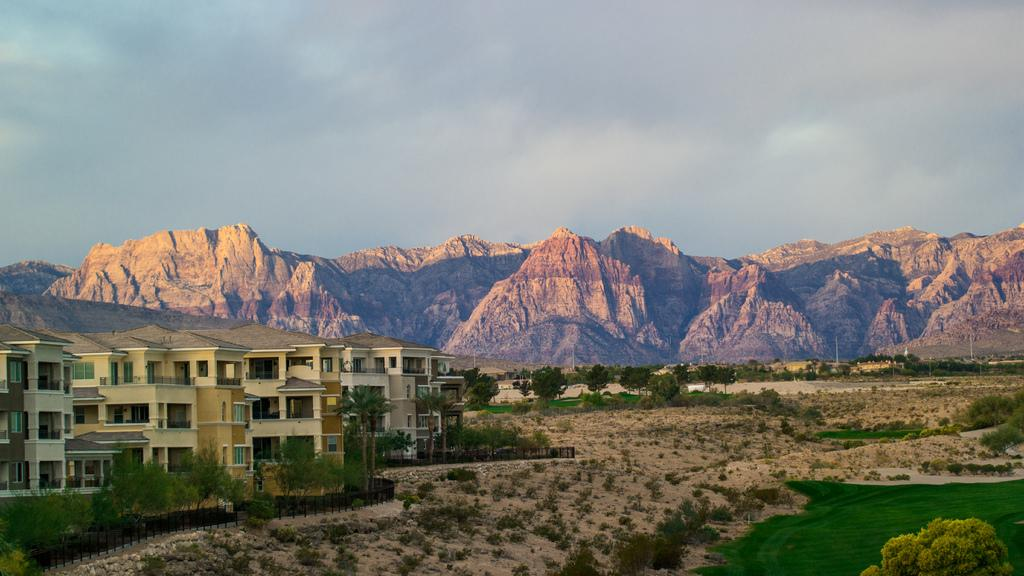What is the condition of the sky in the image? The sky is clear in the image. What type of geographical feature can be seen in the image? There are rocky mountains in the image. What type of vegetation is present in the image? There are trees in the image. What type of man-made structures are visible in the image? There are buildings in the image. What type of toy can be seen in the jar in the image? There is no toy or jar present in the image. 